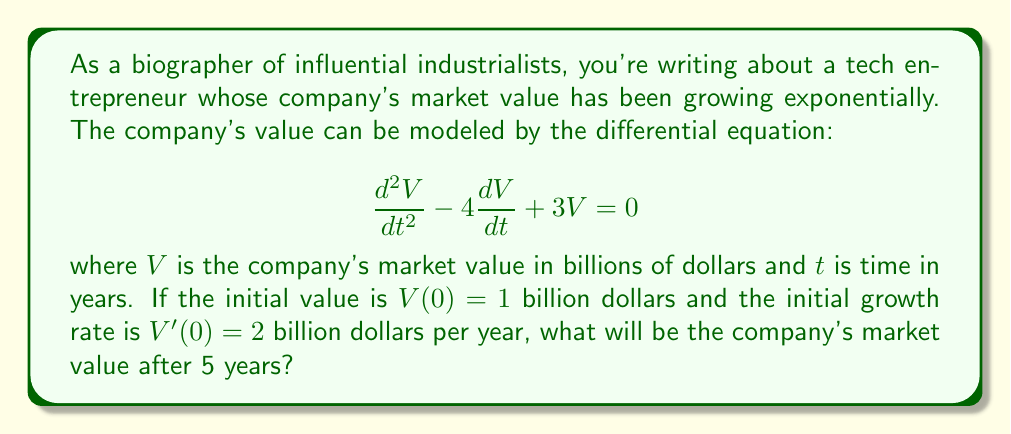Provide a solution to this math problem. To solve this problem, we need to follow these steps:

1) First, we need to find the general solution of the differential equation. The characteristic equation is:

   $$r^2 - 4r + 3 = 0$$

2) Solving this quadratic equation:
   $$(r - 3)(r - 1) = 0$$
   So, $r = 3$ or $r = 1$

3) The general solution is therefore:

   $$V(t) = c_1e^{3t} + c_2e^t$$

4) Now we use the initial conditions to find $c_1$ and $c_2$:

   $V(0) = 1$, so $c_1 + c_2 = 1$
   $V'(0) = 2$, so $3c_1 + c_2 = 2$

5) Solving these simultaneous equations:
   $c_2 = 1 - c_1$
   $3c_1 + (1 - c_1) = 2$
   $2c_1 = 1$
   $c_1 = 0.5$ and $c_2 = 0.5$

6) Therefore, the particular solution is:

   $$V(t) = 0.5e^{3t} + 0.5e^t$$

7) To find the value after 5 years, we calculate $V(5)$:

   $$V(5) = 0.5e^{3(5)} + 0.5e^5$$
   $$= 0.5e^{15} + 0.5e^5$$

8) Using a calculator:

   $$V(5) \approx 1,629,499 + 74.2 \approx 1,629,573$$
Answer: The company's market value after 5 years will be approximately $1,629,573$ billion dollars. 